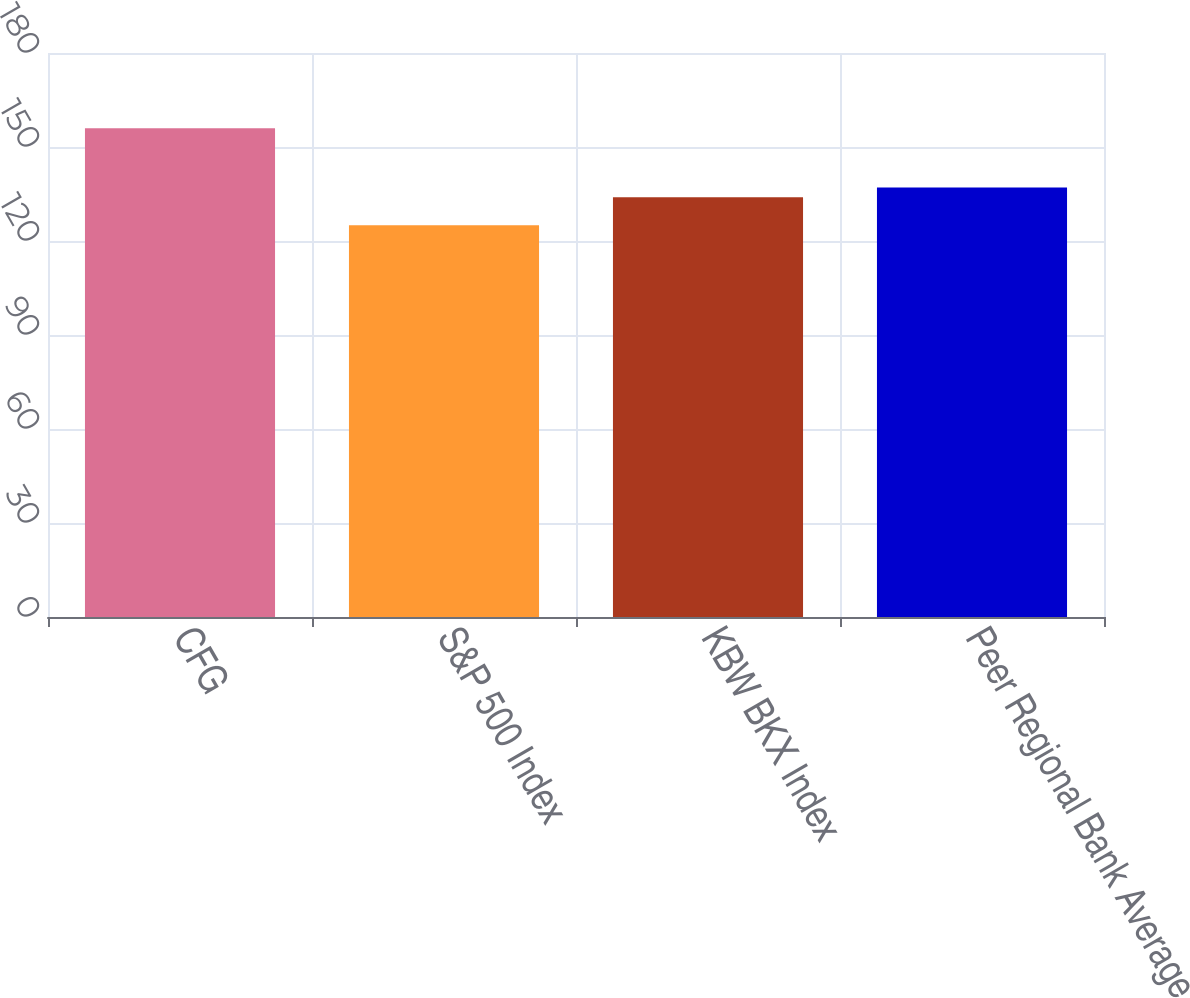Convert chart to OTSL. <chart><loc_0><loc_0><loc_500><loc_500><bar_chart><fcel>CFG<fcel>S&P 500 Index<fcel>KBW BKX Index<fcel>Peer Regional Bank Average<nl><fcel>156<fcel>125<fcel>134<fcel>137.1<nl></chart> 